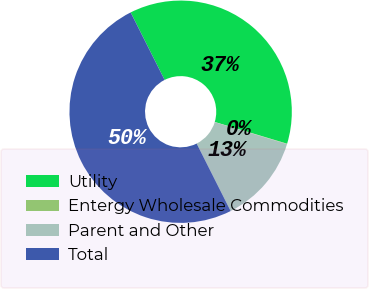Convert chart. <chart><loc_0><loc_0><loc_500><loc_500><pie_chart><fcel>Utility<fcel>Entergy Wholesale Commodities<fcel>Parent and Other<fcel>Total<nl><fcel>37.07%<fcel>0.06%<fcel>12.87%<fcel>50.0%<nl></chart> 